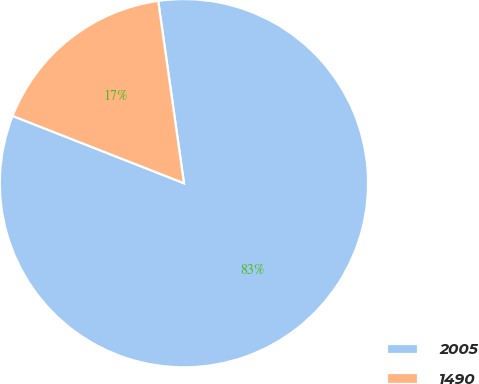Convert chart to OTSL. <chart><loc_0><loc_0><loc_500><loc_500><pie_chart><fcel>2005<fcel>1490<nl><fcel>83.19%<fcel>16.81%<nl></chart> 